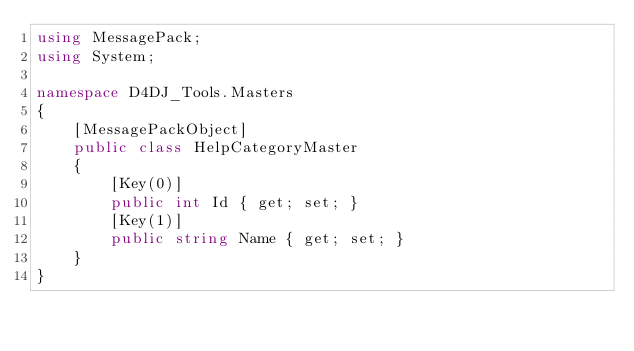Convert code to text. <code><loc_0><loc_0><loc_500><loc_500><_C#_>using MessagePack;
using System;

namespace D4DJ_Tools.Masters
{
	[MessagePackObject]
	public class HelpCategoryMaster
	{
		[Key(0)]
		public int Id { get; set; }
		[Key(1)]
		public string Name { get; set; }
	}
}

</code> 